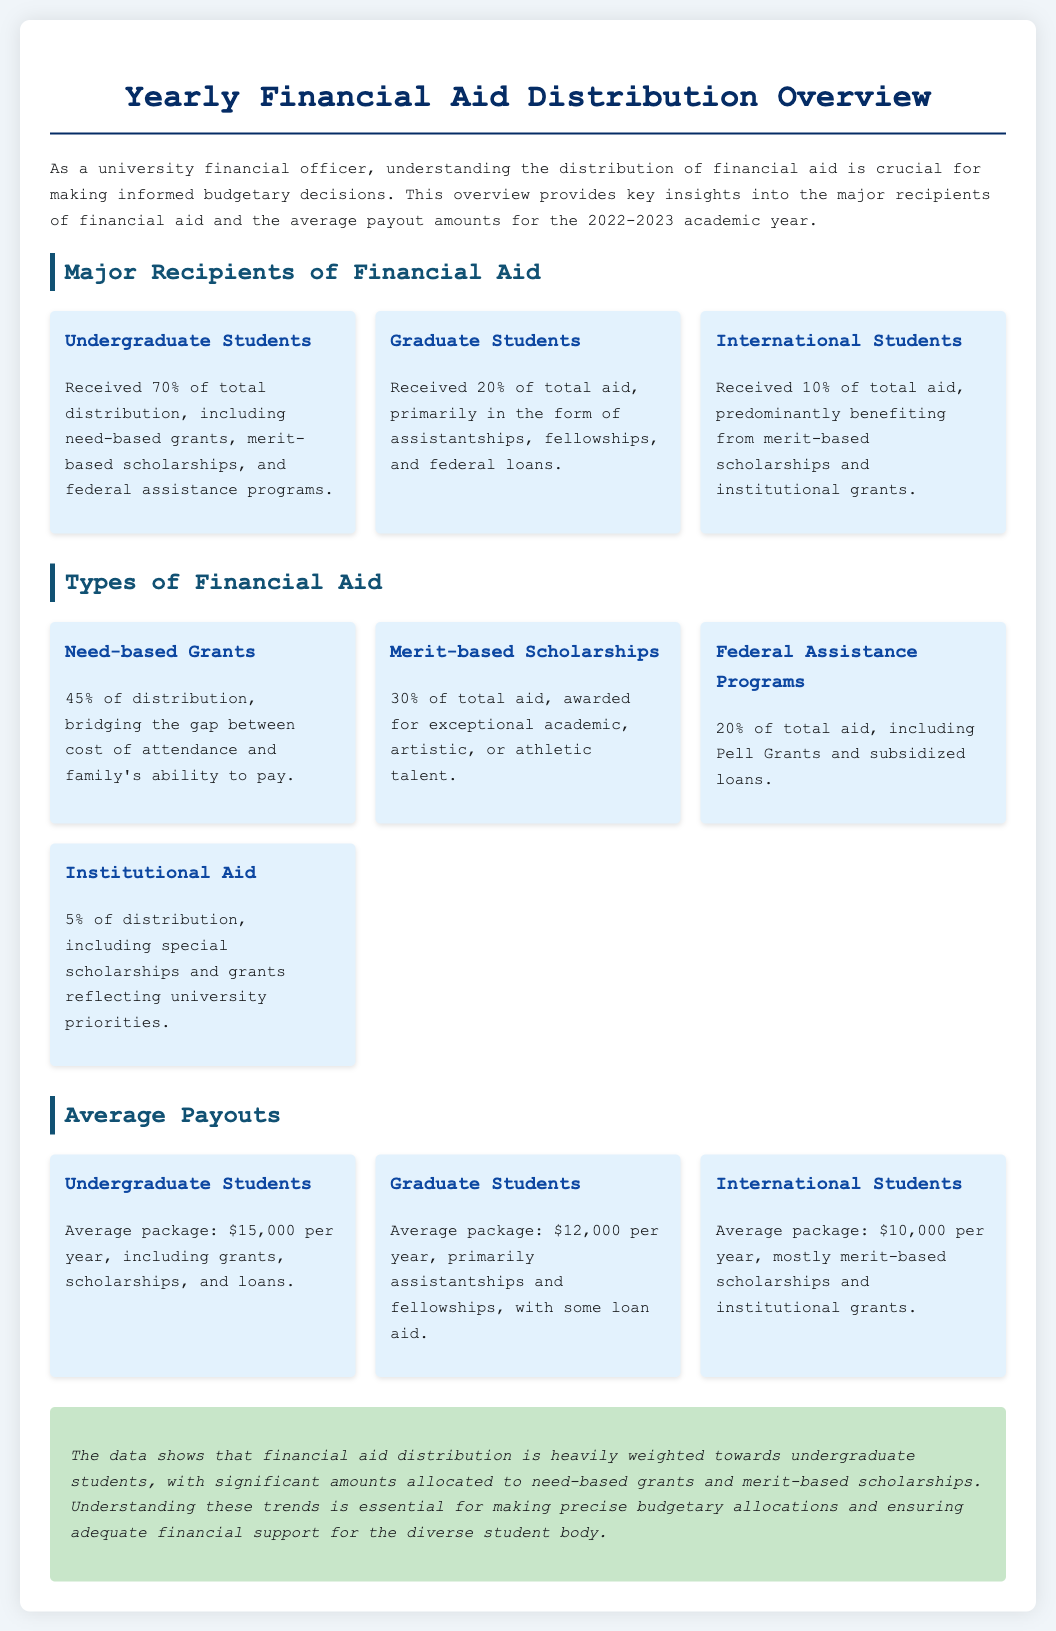What percentage of financial aid is received by undergraduate students? The document states that undergraduate students received 70% of the total distribution.
Answer: 70% What is the average payout for graduate students? The average package for graduate students, as mentioned in the document, is $12,000 per year.
Answer: $12,000 Which group of students received the smallest percentage of financial aid? The document indicates that international students received 10% of the total aid, which is the smallest percentage.
Answer: International Students What is the percentage of total aid allocated to merit-based scholarships? According to the document, merit-based scholarships make up 30% of the total aid distribution.
Answer: 30% What type of financial aid accounts for 45% of the total distribution? The document specifies that need-based grants cover 45% of the financial aid distribution.
Answer: Need-based Grants What is the total percentage of financial aid distributed to graduate and international students combined? The document states that graduate students received 20% and international students 10%, combining for a total of 30%.
Answer: 30% What is the primary form of aid for international students? The document notes that international students predominantly benefit from merit-based scholarships and institutional grants.
Answer: Merit-based scholarships How much financial aid do undergraduate students receive on average per year? The document mentions that undergraduate students receive an average package of $15,000 per year.
Answer: $15,000 